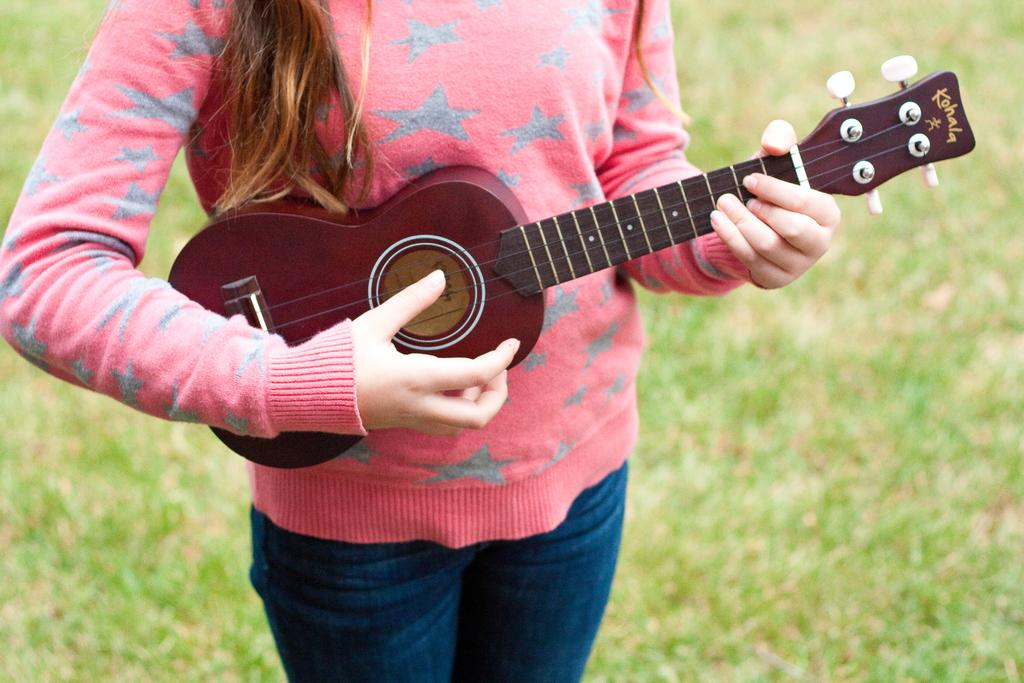Who is the main subject in the image? There is a woman in the image. What is the woman wearing? The woman is wearing a pink dress. What is the woman doing in the image? The woman is playing a guitar. What type of underwear is the woman wearing in the image? There is no information about the woman's underwear in the image, so it cannot be determined. 